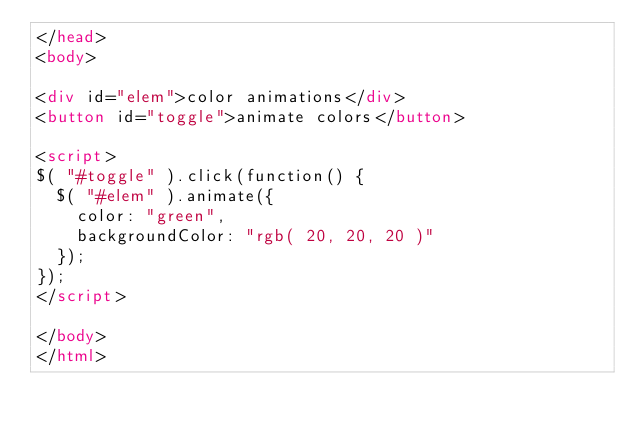<code> <loc_0><loc_0><loc_500><loc_500><_HTML_></head>
<body>

<div id="elem">color animations</div>
<button id="toggle">animate colors</button>

<script>
$( "#toggle" ).click(function() {
	$( "#elem" ).animate({
		color: "green",
		backgroundColor: "rgb( 20, 20, 20 )"
	});
});
</script>

</body>
</html>
</code> 